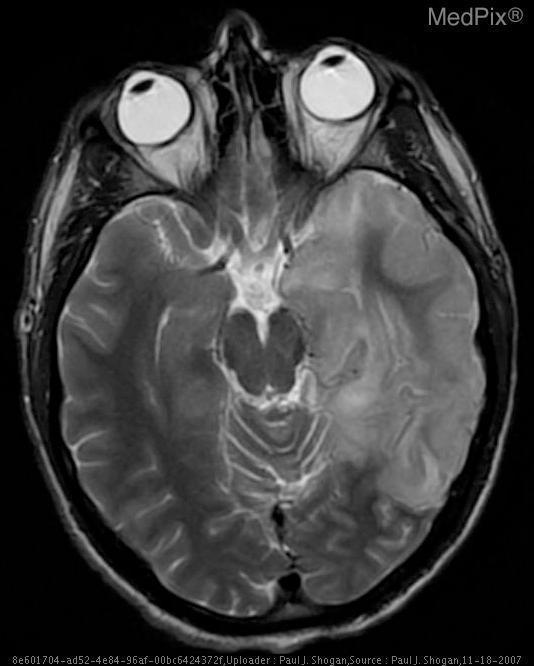Is there swelling of the grey matter?
Quick response, please. Yes. Is this the brain?
Write a very short answer. Yes. Is this a ct image?
Be succinct. No. In what plane is this image oriented?
Quick response, please. Axial. Is there a skull fracture pictured?
Give a very brief answer. No. Where is the abnormality?
Answer briefly. Left temporal lobe. 